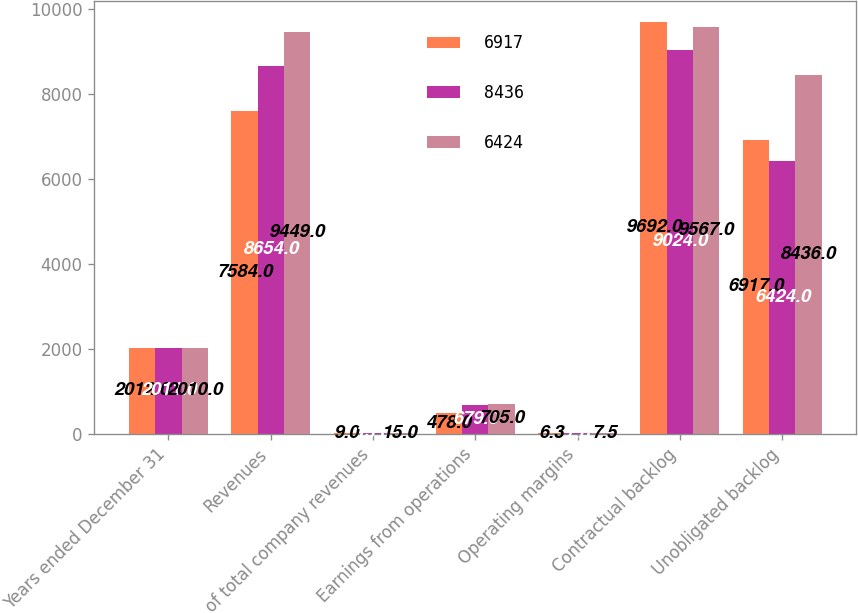Convert chart to OTSL. <chart><loc_0><loc_0><loc_500><loc_500><stacked_bar_chart><ecel><fcel>Years ended December 31<fcel>Revenues<fcel>of total company revenues<fcel>Earnings from operations<fcel>Operating margins<fcel>Contractual backlog<fcel>Unobligated backlog<nl><fcel>6917<fcel>2012<fcel>7584<fcel>9<fcel>478<fcel>6.3<fcel>9692<fcel>6917<nl><fcel>8436<fcel>2011<fcel>8654<fcel>13<fcel>679<fcel>7.8<fcel>9024<fcel>6424<nl><fcel>6424<fcel>2010<fcel>9449<fcel>15<fcel>705<fcel>7.5<fcel>9567<fcel>8436<nl></chart> 